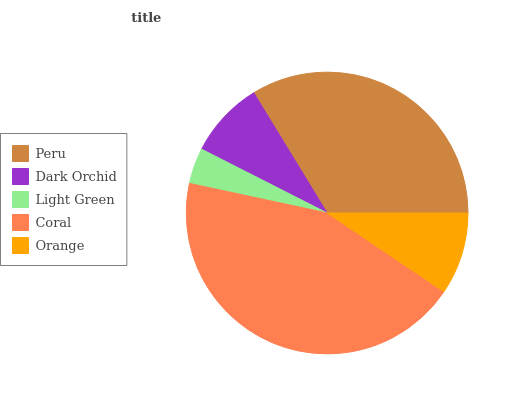Is Light Green the minimum?
Answer yes or no. Yes. Is Coral the maximum?
Answer yes or no. Yes. Is Dark Orchid the minimum?
Answer yes or no. No. Is Dark Orchid the maximum?
Answer yes or no. No. Is Peru greater than Dark Orchid?
Answer yes or no. Yes. Is Dark Orchid less than Peru?
Answer yes or no. Yes. Is Dark Orchid greater than Peru?
Answer yes or no. No. Is Peru less than Dark Orchid?
Answer yes or no. No. Is Orange the high median?
Answer yes or no. Yes. Is Orange the low median?
Answer yes or no. Yes. Is Coral the high median?
Answer yes or no. No. Is Light Green the low median?
Answer yes or no. No. 